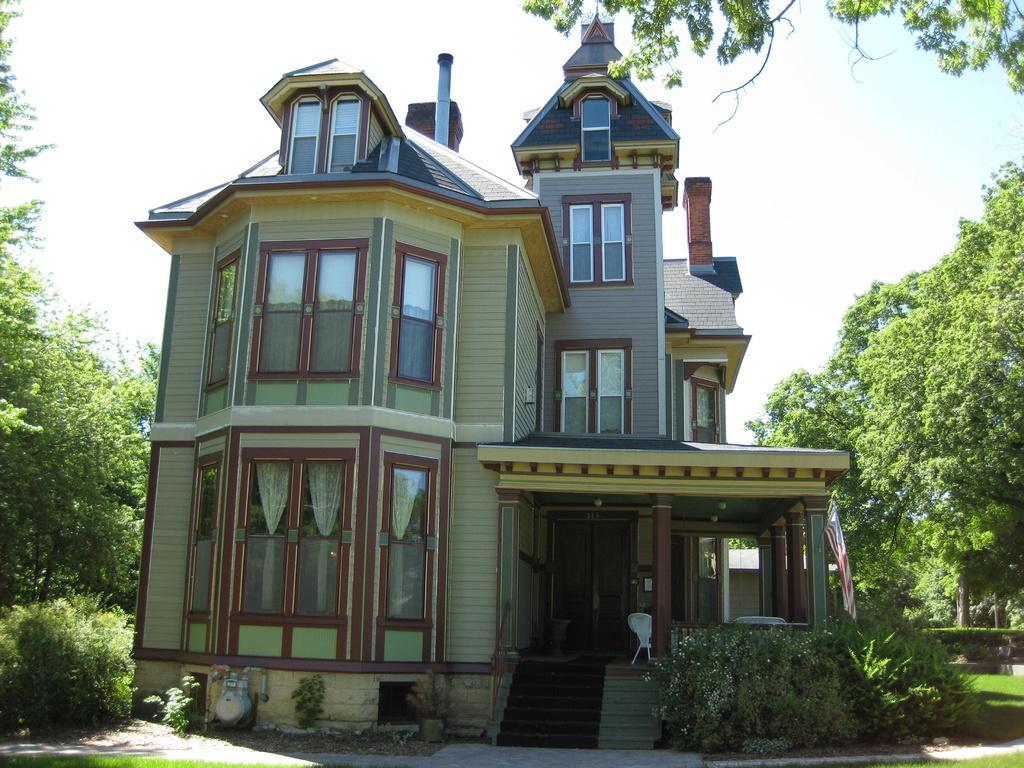Describe this image in one or two sentences. In this image I can see in the middle there is a house with glass windows, there are trees on either side of this image. At the top it is the sky. 